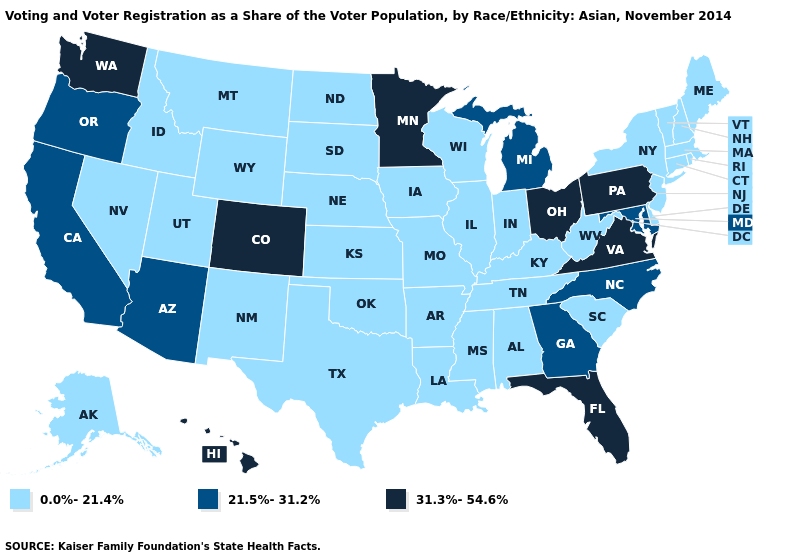Does Iowa have the same value as California?
Be succinct. No. Which states have the lowest value in the Northeast?
Keep it brief. Connecticut, Maine, Massachusetts, New Hampshire, New Jersey, New York, Rhode Island, Vermont. Name the states that have a value in the range 0.0%-21.4%?
Concise answer only. Alabama, Alaska, Arkansas, Connecticut, Delaware, Idaho, Illinois, Indiana, Iowa, Kansas, Kentucky, Louisiana, Maine, Massachusetts, Mississippi, Missouri, Montana, Nebraska, Nevada, New Hampshire, New Jersey, New Mexico, New York, North Dakota, Oklahoma, Rhode Island, South Carolina, South Dakota, Tennessee, Texas, Utah, Vermont, West Virginia, Wisconsin, Wyoming. Name the states that have a value in the range 0.0%-21.4%?
Give a very brief answer. Alabama, Alaska, Arkansas, Connecticut, Delaware, Idaho, Illinois, Indiana, Iowa, Kansas, Kentucky, Louisiana, Maine, Massachusetts, Mississippi, Missouri, Montana, Nebraska, Nevada, New Hampshire, New Jersey, New Mexico, New York, North Dakota, Oklahoma, Rhode Island, South Carolina, South Dakota, Tennessee, Texas, Utah, Vermont, West Virginia, Wisconsin, Wyoming. Name the states that have a value in the range 0.0%-21.4%?
Keep it brief. Alabama, Alaska, Arkansas, Connecticut, Delaware, Idaho, Illinois, Indiana, Iowa, Kansas, Kentucky, Louisiana, Maine, Massachusetts, Mississippi, Missouri, Montana, Nebraska, Nevada, New Hampshire, New Jersey, New Mexico, New York, North Dakota, Oklahoma, Rhode Island, South Carolina, South Dakota, Tennessee, Texas, Utah, Vermont, West Virginia, Wisconsin, Wyoming. Does the map have missing data?
Quick response, please. No. What is the highest value in the USA?
Write a very short answer. 31.3%-54.6%. What is the value of Alabama?
Short answer required. 0.0%-21.4%. Name the states that have a value in the range 31.3%-54.6%?
Answer briefly. Colorado, Florida, Hawaii, Minnesota, Ohio, Pennsylvania, Virginia, Washington. What is the lowest value in states that border Rhode Island?
Give a very brief answer. 0.0%-21.4%. Does Vermont have a lower value than New Mexico?
Concise answer only. No. What is the value of New Hampshire?
Quick response, please. 0.0%-21.4%. What is the value of North Dakota?
Short answer required. 0.0%-21.4%. Which states have the lowest value in the South?
Quick response, please. Alabama, Arkansas, Delaware, Kentucky, Louisiana, Mississippi, Oklahoma, South Carolina, Tennessee, Texas, West Virginia. Name the states that have a value in the range 31.3%-54.6%?
Keep it brief. Colorado, Florida, Hawaii, Minnesota, Ohio, Pennsylvania, Virginia, Washington. 